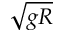<formula> <loc_0><loc_0><loc_500><loc_500>\sqrt { g R }</formula> 